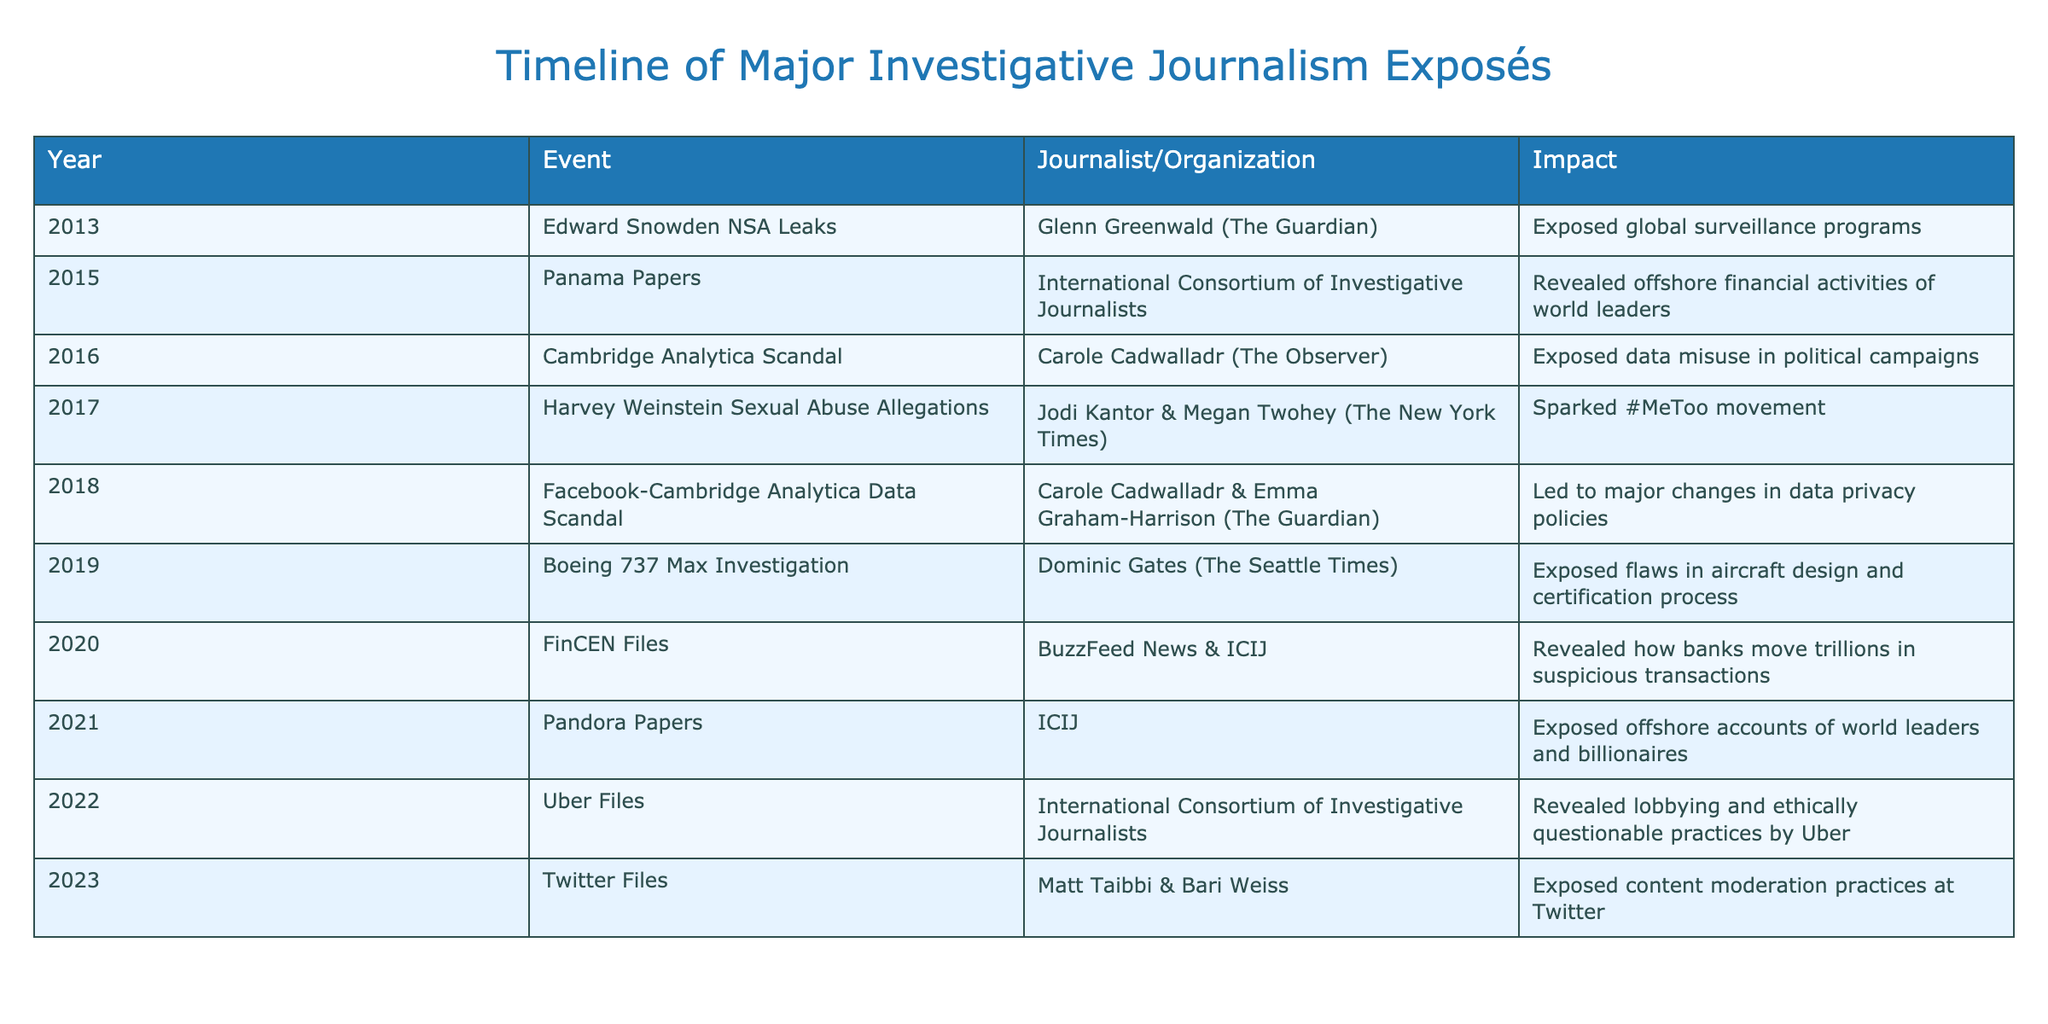What year did the Panama Papers get published? The table lists the events chronologically by year. By locating "Panama Papers," which is in the second row, it is clear that the year of publication is 2015.
Answer: 2015 Who was the journalist behind the Edward Snowden NSA leaks? The table specifies the event "Edward Snowden NSA Leaks" in the first row. The corresponding column for the journalist reveals that it was Glenn Greenwald from The Guardian.
Answer: Glenn Greenwald What is the impact of the Cambridge Analytica scandal? To find the impact, look for "Cambridge Analytica Scandal" in the table, which is listed in 2016. The impact specified in the corresponding cell details that it exposed data misuse in political campaigns.
Answer: Exposed data misuse in political campaigns How many exposés involved the International Consortium of Investigative Journalists (ICIJ)? ICIJ is mentioned as the journalist/organization for the Panama Papers (2015), FinCEN Files (2020), and Pandora Papers (2021). This makes a total of three instances.
Answer: 3 Did the Harvey Weinstein allegations contribute to a movement? By checking the row for "Harvey Weinstein Sexual Abuse Allegations," it is indicated that this exposé sparked the #MeToo movement, confirming that the claim is true.
Answer: Yes Which event led to changes in data privacy policies? The table includes the "Facebook-Cambridge Analytica Data Scandal" in 2018. The impact stated in that row notes it led to significant changes in data privacy policies, confirming the event's significance.
Answer: Facebook-Cambridge Analytica Data Scandal What was the difference in years between the Panama Papers and the Twitter Files? The Panama Papers occurred in 2015, and the Twitter Files were published in 2023. The difference in years is calculated by subtracting 2015 from 2023, which equals 8 years.
Answer: 8 years How many major events occurred in 2020? The table shows the events listed for that year, and only one entry, "FinCEN Files," is listed, indicating that there was only one major investigative journalism exposé in 2020.
Answer: 1 Which event's impact was to reveal flaws in the aircraft design? Referring to the data for "Boeing 737 Max Investigation" listed in 2019, the impact clearly states that it exposed flaws in the aircraft design and certification process.
Answer: Boeing 737 Max Investigation 